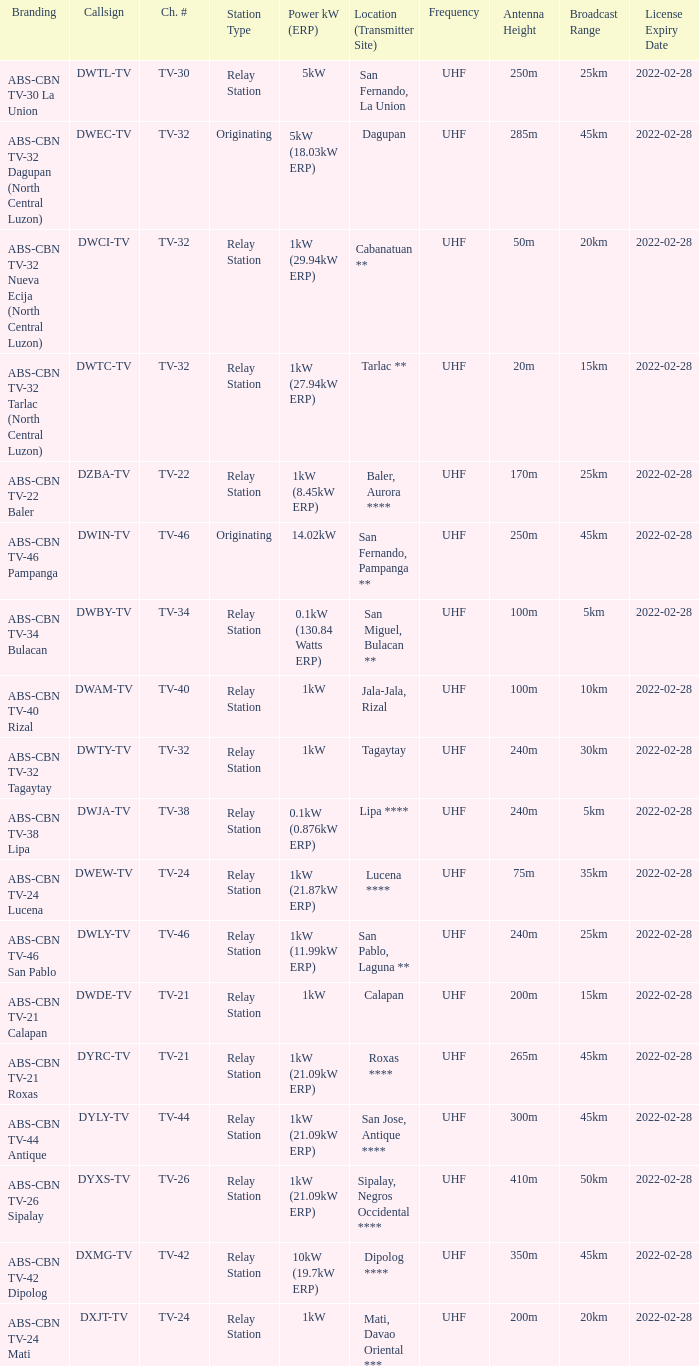What is the branding of the callsign DWCI-TV? ABS-CBN TV-32 Nueva Ecija (North Central Luzon). 